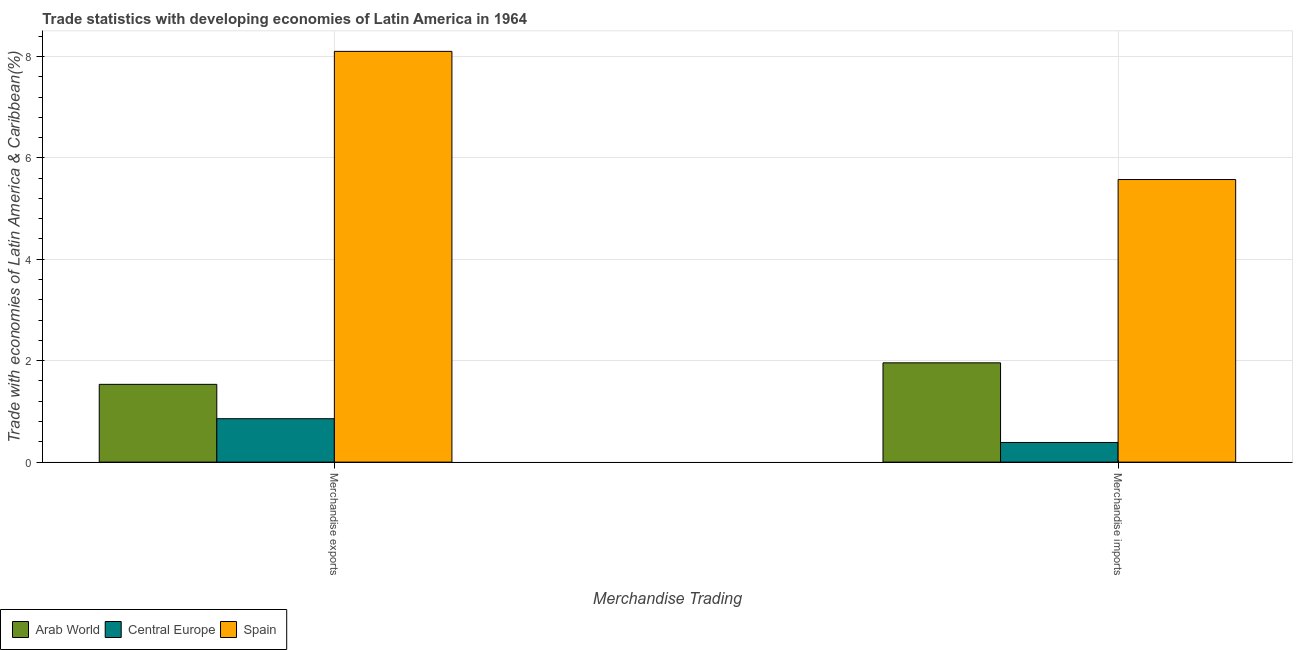How many groups of bars are there?
Your answer should be compact. 2. Are the number of bars per tick equal to the number of legend labels?
Offer a very short reply. Yes. What is the label of the 2nd group of bars from the left?
Keep it short and to the point. Merchandise imports. What is the merchandise imports in Central Europe?
Provide a succinct answer. 0.39. Across all countries, what is the maximum merchandise exports?
Ensure brevity in your answer.  8.1. Across all countries, what is the minimum merchandise imports?
Offer a very short reply. 0.39. In which country was the merchandise imports minimum?
Your answer should be very brief. Central Europe. What is the total merchandise exports in the graph?
Keep it short and to the point. 10.49. What is the difference between the merchandise imports in Central Europe and that in Spain?
Offer a very short reply. -5.18. What is the difference between the merchandise exports in Arab World and the merchandise imports in Spain?
Keep it short and to the point. -4.04. What is the average merchandise imports per country?
Provide a short and direct response. 2.64. What is the difference between the merchandise imports and merchandise exports in Spain?
Keep it short and to the point. -2.53. In how many countries, is the merchandise exports greater than 3.2 %?
Offer a very short reply. 1. What is the ratio of the merchandise exports in Central Europe to that in Spain?
Provide a short and direct response. 0.11. Is the merchandise exports in Spain less than that in Arab World?
Provide a succinct answer. No. What does the 1st bar from the right in Merchandise exports represents?
Offer a terse response. Spain. Are all the bars in the graph horizontal?
Provide a succinct answer. No. How many countries are there in the graph?
Offer a very short reply. 3. Where does the legend appear in the graph?
Offer a terse response. Bottom left. How are the legend labels stacked?
Offer a terse response. Horizontal. What is the title of the graph?
Keep it short and to the point. Trade statistics with developing economies of Latin America in 1964. Does "Chad" appear as one of the legend labels in the graph?
Your answer should be very brief. No. What is the label or title of the X-axis?
Offer a very short reply. Merchandise Trading. What is the label or title of the Y-axis?
Offer a very short reply. Trade with economies of Latin America & Caribbean(%). What is the Trade with economies of Latin America & Caribbean(%) in Arab World in Merchandise exports?
Your answer should be very brief. 1.53. What is the Trade with economies of Latin America & Caribbean(%) of Central Europe in Merchandise exports?
Your answer should be compact. 0.86. What is the Trade with economies of Latin America & Caribbean(%) in Spain in Merchandise exports?
Offer a very short reply. 8.1. What is the Trade with economies of Latin America & Caribbean(%) in Arab World in Merchandise imports?
Offer a terse response. 1.96. What is the Trade with economies of Latin America & Caribbean(%) of Central Europe in Merchandise imports?
Your answer should be compact. 0.39. What is the Trade with economies of Latin America & Caribbean(%) of Spain in Merchandise imports?
Your answer should be very brief. 5.57. Across all Merchandise Trading, what is the maximum Trade with economies of Latin America & Caribbean(%) in Arab World?
Your response must be concise. 1.96. Across all Merchandise Trading, what is the maximum Trade with economies of Latin America & Caribbean(%) in Central Europe?
Your answer should be very brief. 0.86. Across all Merchandise Trading, what is the maximum Trade with economies of Latin America & Caribbean(%) of Spain?
Ensure brevity in your answer.  8.1. Across all Merchandise Trading, what is the minimum Trade with economies of Latin America & Caribbean(%) of Arab World?
Provide a succinct answer. 1.53. Across all Merchandise Trading, what is the minimum Trade with economies of Latin America & Caribbean(%) in Central Europe?
Keep it short and to the point. 0.39. Across all Merchandise Trading, what is the minimum Trade with economies of Latin America & Caribbean(%) in Spain?
Ensure brevity in your answer.  5.57. What is the total Trade with economies of Latin America & Caribbean(%) in Arab World in the graph?
Your response must be concise. 3.49. What is the total Trade with economies of Latin America & Caribbean(%) of Central Europe in the graph?
Provide a succinct answer. 1.24. What is the total Trade with economies of Latin America & Caribbean(%) of Spain in the graph?
Give a very brief answer. 13.67. What is the difference between the Trade with economies of Latin America & Caribbean(%) in Arab World in Merchandise exports and that in Merchandise imports?
Provide a succinct answer. -0.42. What is the difference between the Trade with economies of Latin America & Caribbean(%) of Central Europe in Merchandise exports and that in Merchandise imports?
Offer a very short reply. 0.47. What is the difference between the Trade with economies of Latin America & Caribbean(%) in Spain in Merchandise exports and that in Merchandise imports?
Your response must be concise. 2.53. What is the difference between the Trade with economies of Latin America & Caribbean(%) in Arab World in Merchandise exports and the Trade with economies of Latin America & Caribbean(%) in Central Europe in Merchandise imports?
Offer a terse response. 1.15. What is the difference between the Trade with economies of Latin America & Caribbean(%) of Arab World in Merchandise exports and the Trade with economies of Latin America & Caribbean(%) of Spain in Merchandise imports?
Ensure brevity in your answer.  -4.04. What is the difference between the Trade with economies of Latin America & Caribbean(%) of Central Europe in Merchandise exports and the Trade with economies of Latin America & Caribbean(%) of Spain in Merchandise imports?
Provide a succinct answer. -4.72. What is the average Trade with economies of Latin America & Caribbean(%) of Arab World per Merchandise Trading?
Make the answer very short. 1.75. What is the average Trade with economies of Latin America & Caribbean(%) in Central Europe per Merchandise Trading?
Give a very brief answer. 0.62. What is the average Trade with economies of Latin America & Caribbean(%) in Spain per Merchandise Trading?
Your response must be concise. 6.84. What is the difference between the Trade with economies of Latin America & Caribbean(%) of Arab World and Trade with economies of Latin America & Caribbean(%) of Central Europe in Merchandise exports?
Offer a terse response. 0.68. What is the difference between the Trade with economies of Latin America & Caribbean(%) of Arab World and Trade with economies of Latin America & Caribbean(%) of Spain in Merchandise exports?
Provide a succinct answer. -6.57. What is the difference between the Trade with economies of Latin America & Caribbean(%) of Central Europe and Trade with economies of Latin America & Caribbean(%) of Spain in Merchandise exports?
Offer a terse response. -7.24. What is the difference between the Trade with economies of Latin America & Caribbean(%) in Arab World and Trade with economies of Latin America & Caribbean(%) in Central Europe in Merchandise imports?
Your response must be concise. 1.57. What is the difference between the Trade with economies of Latin America & Caribbean(%) of Arab World and Trade with economies of Latin America & Caribbean(%) of Spain in Merchandise imports?
Your response must be concise. -3.61. What is the difference between the Trade with economies of Latin America & Caribbean(%) of Central Europe and Trade with economies of Latin America & Caribbean(%) of Spain in Merchandise imports?
Your response must be concise. -5.18. What is the ratio of the Trade with economies of Latin America & Caribbean(%) of Arab World in Merchandise exports to that in Merchandise imports?
Keep it short and to the point. 0.78. What is the ratio of the Trade with economies of Latin America & Caribbean(%) of Central Europe in Merchandise exports to that in Merchandise imports?
Ensure brevity in your answer.  2.21. What is the ratio of the Trade with economies of Latin America & Caribbean(%) in Spain in Merchandise exports to that in Merchandise imports?
Ensure brevity in your answer.  1.45. What is the difference between the highest and the second highest Trade with economies of Latin America & Caribbean(%) in Arab World?
Provide a succinct answer. 0.42. What is the difference between the highest and the second highest Trade with economies of Latin America & Caribbean(%) in Central Europe?
Give a very brief answer. 0.47. What is the difference between the highest and the second highest Trade with economies of Latin America & Caribbean(%) of Spain?
Ensure brevity in your answer.  2.53. What is the difference between the highest and the lowest Trade with economies of Latin America & Caribbean(%) of Arab World?
Your answer should be very brief. 0.42. What is the difference between the highest and the lowest Trade with economies of Latin America & Caribbean(%) in Central Europe?
Offer a terse response. 0.47. What is the difference between the highest and the lowest Trade with economies of Latin America & Caribbean(%) of Spain?
Give a very brief answer. 2.53. 